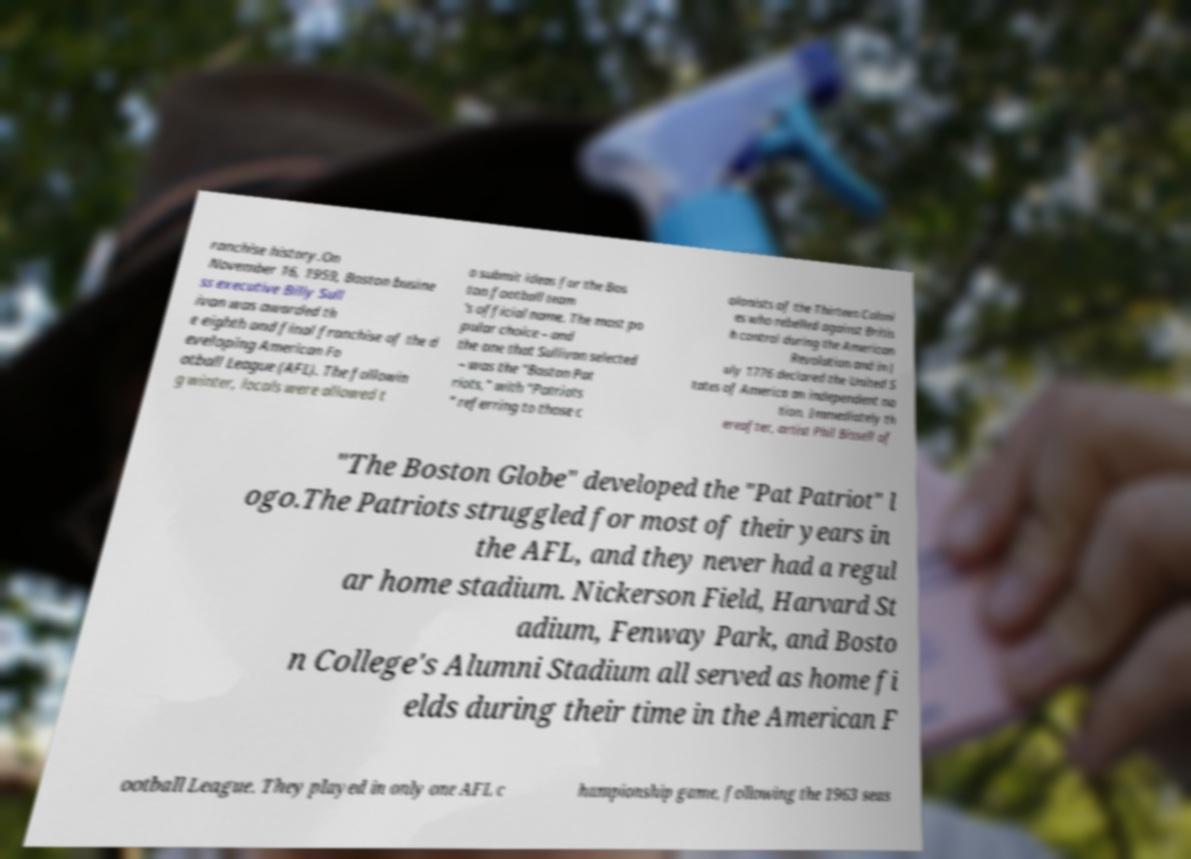Can you accurately transcribe the text from the provided image for me? ranchise history.On November 16, 1959, Boston busine ss executive Billy Sull ivan was awarded th e eighth and final franchise of the d eveloping American Fo otball League (AFL). The followin g winter, locals were allowed t o submit ideas for the Bos ton football team 's official name. The most po pular choice – and the one that Sullivan selected – was the "Boston Pat riots," with "Patriots " referring to those c olonists of the Thirteen Coloni es who rebelled against Britis h control during the American Revolution and in J uly 1776 declared the United S tates of America an independent na tion. Immediately th ereafter, artist Phil Bissell of "The Boston Globe" developed the "Pat Patriot" l ogo.The Patriots struggled for most of their years in the AFL, and they never had a regul ar home stadium. Nickerson Field, Harvard St adium, Fenway Park, and Bosto n College's Alumni Stadium all served as home fi elds during their time in the American F ootball League. They played in only one AFL c hampionship game, following the 1963 seas 